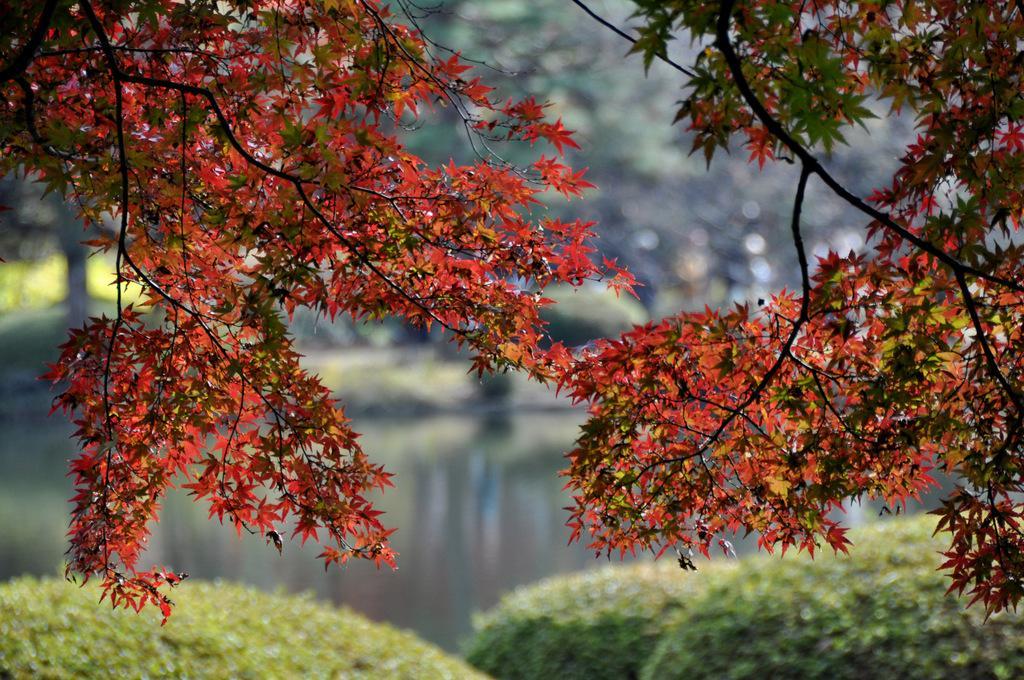Describe this image in one or two sentences. In this picture I can see trees, there is water, and there is blur background. 